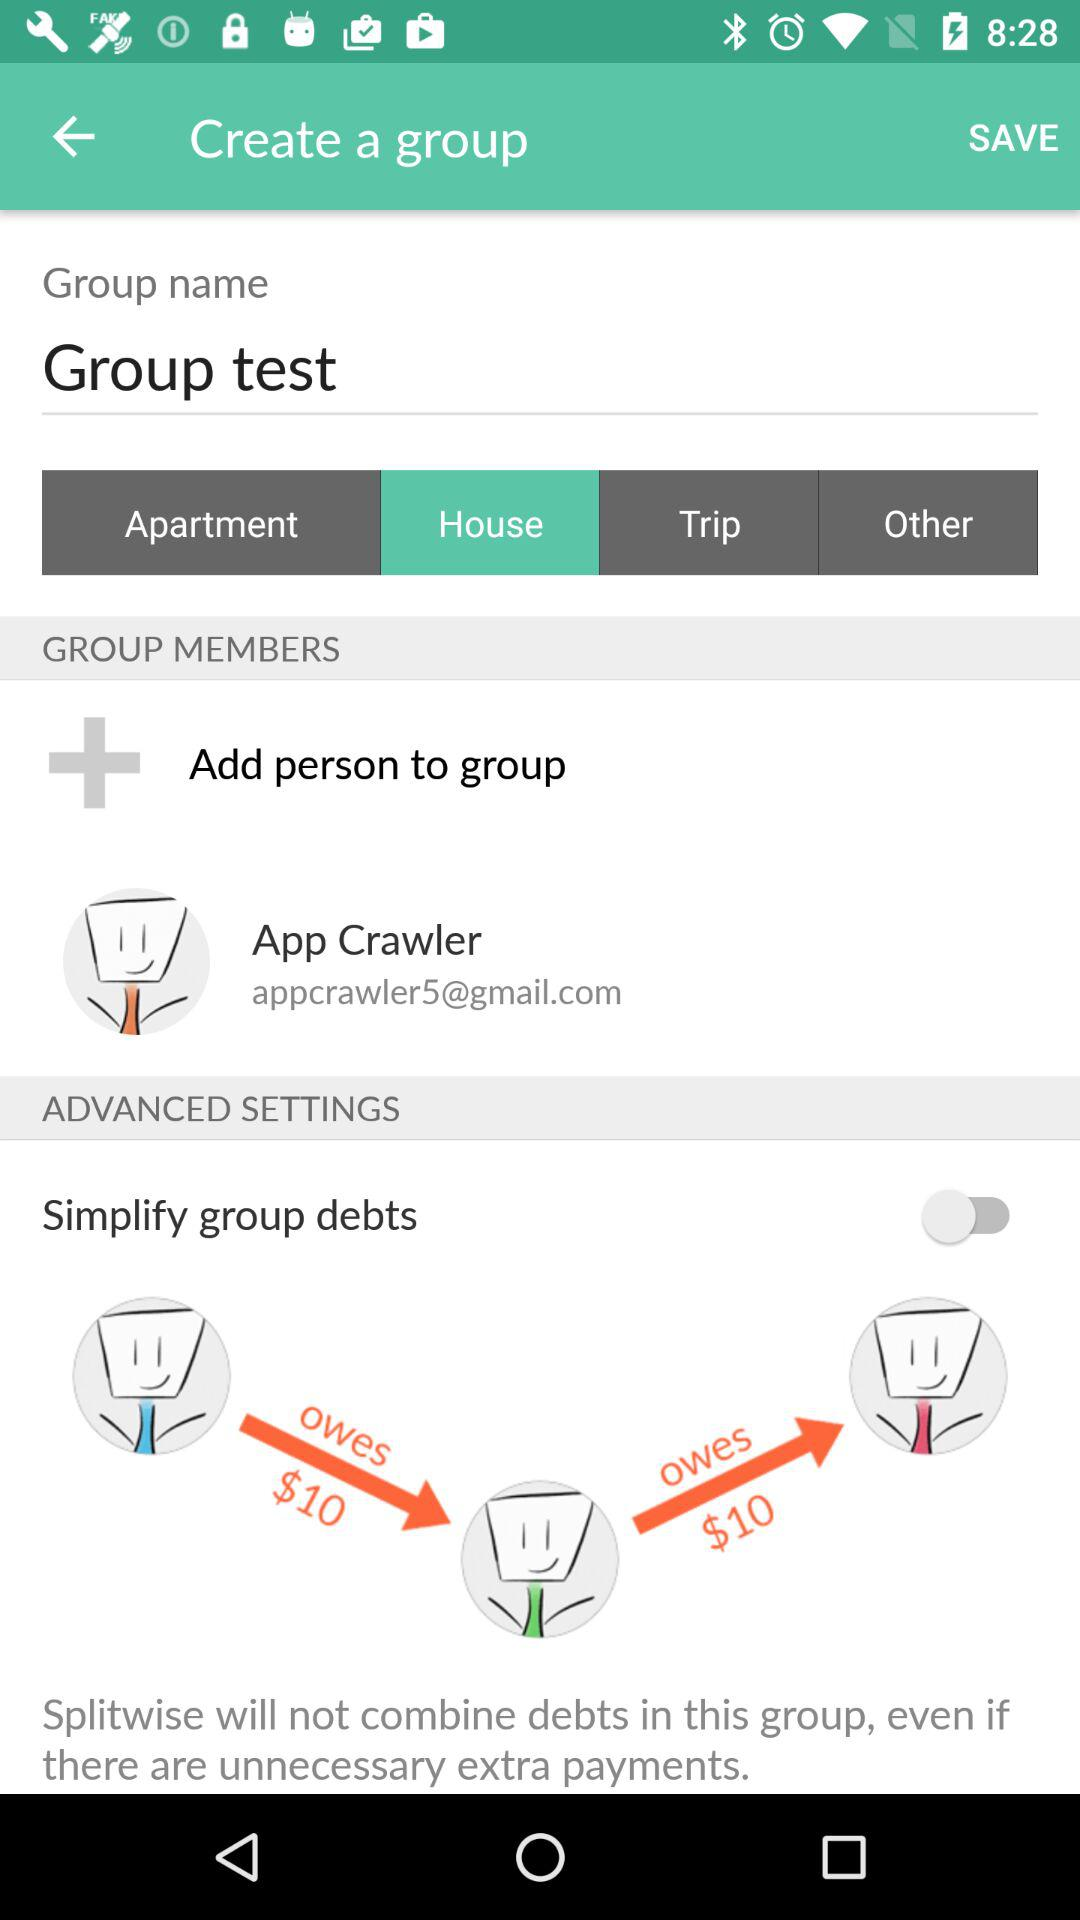What is the name of the group? The name of the group is "Group test". 